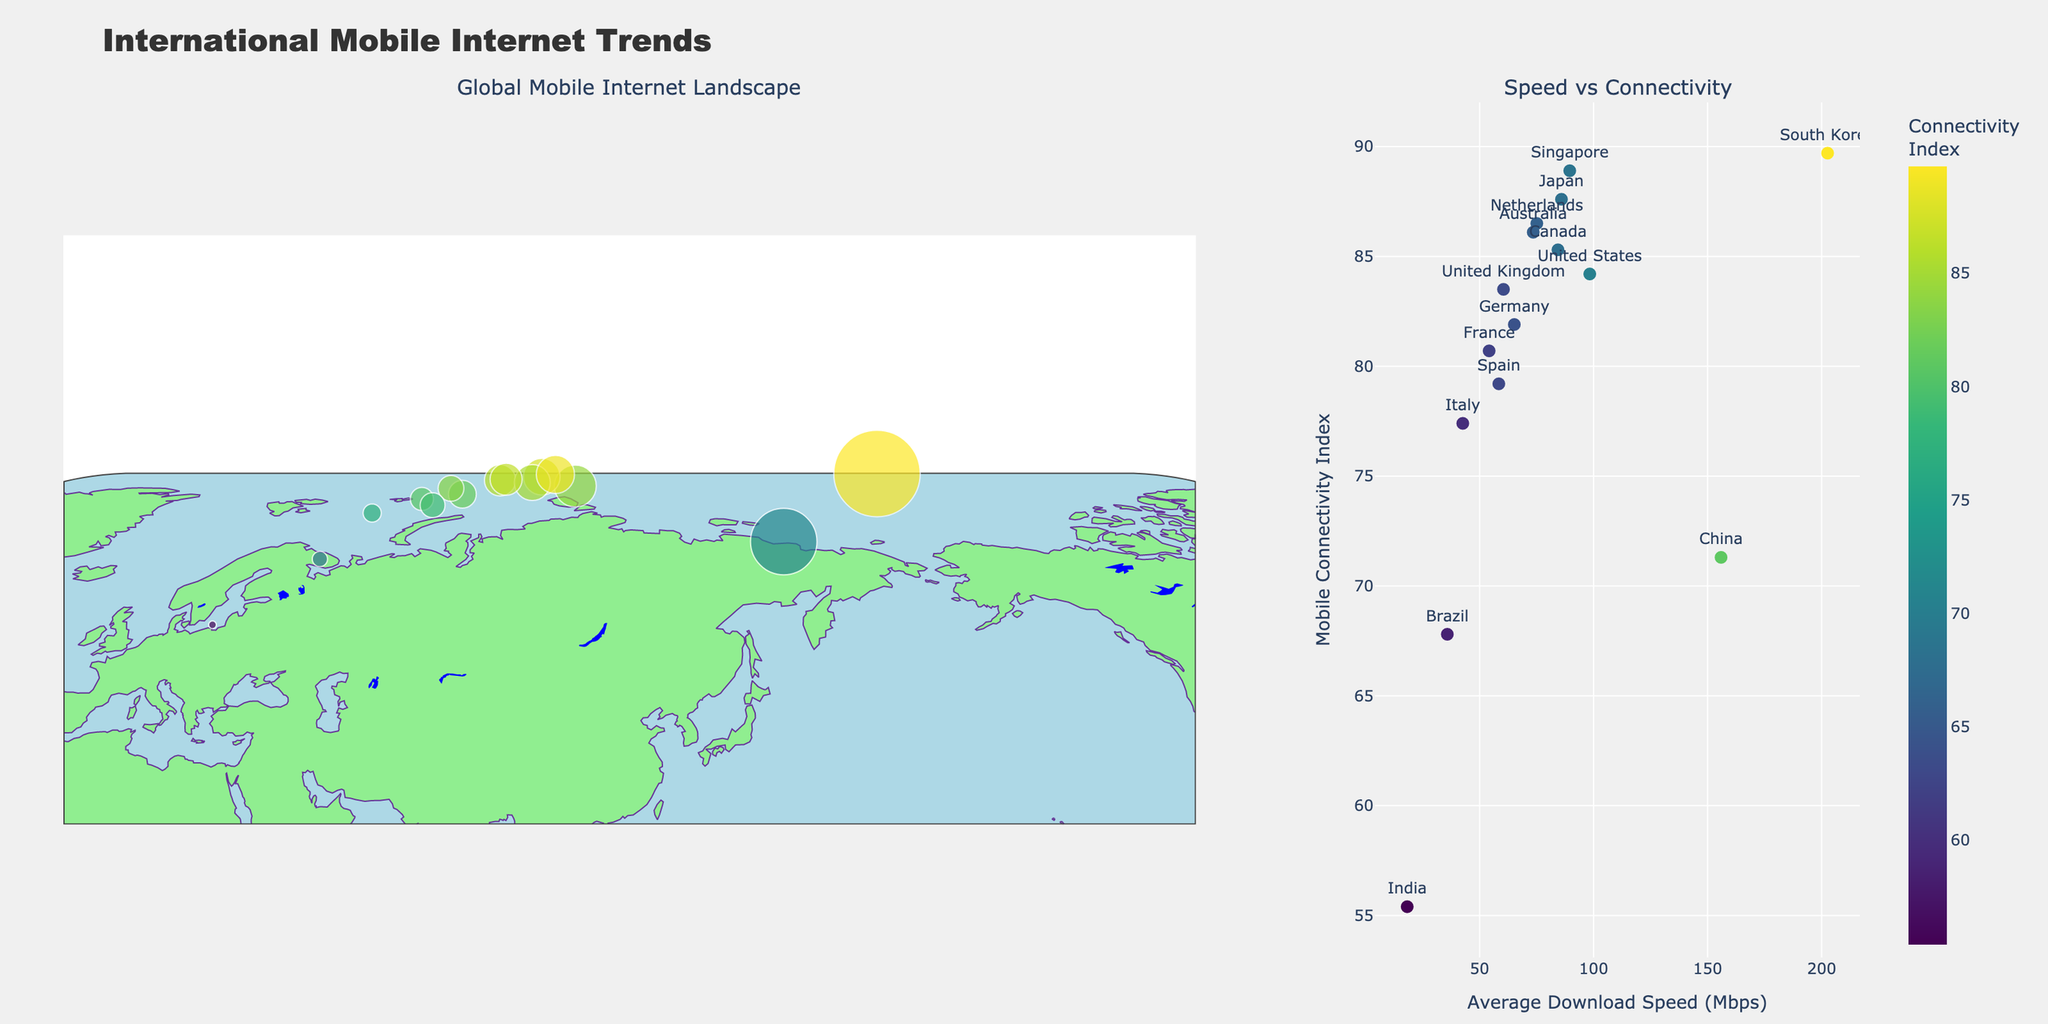What is the title of the figure? The title is prominently displayed at the top of the figure. It reads "International Mobile Internet Trends."
Answer: International Mobile Internet Trends How many countries are represented in the plot? By counting the unique data points or markers present in the scatter plots, we observe there are 15 countries.
Answer: 15 Which country has the highest average download speed? By looking at the average download speed values, South Korea has the highest with 202.61 Mbps.
Answer: South Korea Which country has the lowest mobile connectivity index, and what is its value? By comparing the mobile connectivity indices, India has the lowest with a value of 55.4.
Answer: India with 55.4 What is the average download speed of South Korea, and how does it compare to India? South Korea's average download speed is 202.61 Mbps while India's is 18.26 Mbps. The difference is 202.61 - 18.26 = 184.35 Mbps.
Answer: 184.35 Mbps Which two countries have the closest average download speeds, and what are their values? By closely examining the average download speeds, Japan (85.91 Mbps) and Canada (84.37 Mbps) have the closest values, with a difference of only 1.54 Mbps.
Answer: Japan (85.91 Mbps) and Canada (84.37 Mbps) Is there a general correlation between download speed and connectivity index? By observing the scatter plot on the right, a positive correlation can be seen, indicating that countries with higher download speeds generally have higher connectivity indices.
Answer: Yes, positive correlation Which country is an outlier in terms of mobile connectivity index compared to its average download speed? Observing the scatter plot, China stands out as having a much higher average download speed (155.89 Mbps) compared to its relatively lower connectivity index (71.3).
Answer: China What popular app category is associated with the United Kingdom, and what is its connectivity index? According to the text information on the markers, the popular app category for the United Kingdom is "Health & Fitness," and its connectivity index is 83.5.
Answer: Health & Fitness with 83.5 Determine the sum of the average download speeds of Germany, France, and Italy. Adding the average download speeds of Germany (65.23 Mbps), France (54.19 Mbps), and Italy (42.63 Mbps), we get: 65.23 + 54.19 + 42.63 = 162.05 Mbps.
Answer: 162.05 Mbps 